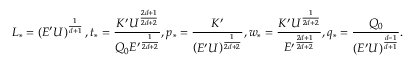Convert formula to latex. <formula><loc_0><loc_0><loc_500><loc_500>L _ { * } = \left ( E ^ { \prime } U \right ) ^ { \frac { 1 } { d + 1 } } , t _ { * } = \frac { K ^ { \prime } U ^ { \frac { 2 d + 1 } { 2 d + 2 } } } { Q _ { 0 } { E ^ { \prime } } ^ { \frac { 1 } { 2 d + 2 } } } , p _ { * } = \frac { K ^ { \prime } } { \left ( E ^ { \prime } U \right ) ^ { \frac { 1 } { 2 d + 2 } } } , w _ { * } = \frac { K ^ { \prime } U ^ { \frac { 1 } { 2 d + 2 } } } { { E ^ { \prime } } ^ { \frac { 2 d + 1 } { 2 d + 2 } } } , q _ { * } = \frac { Q _ { 0 } } { \left ( E ^ { \prime } U \right ) ^ { \frac { d - 1 } { d + 1 } } } .</formula> 